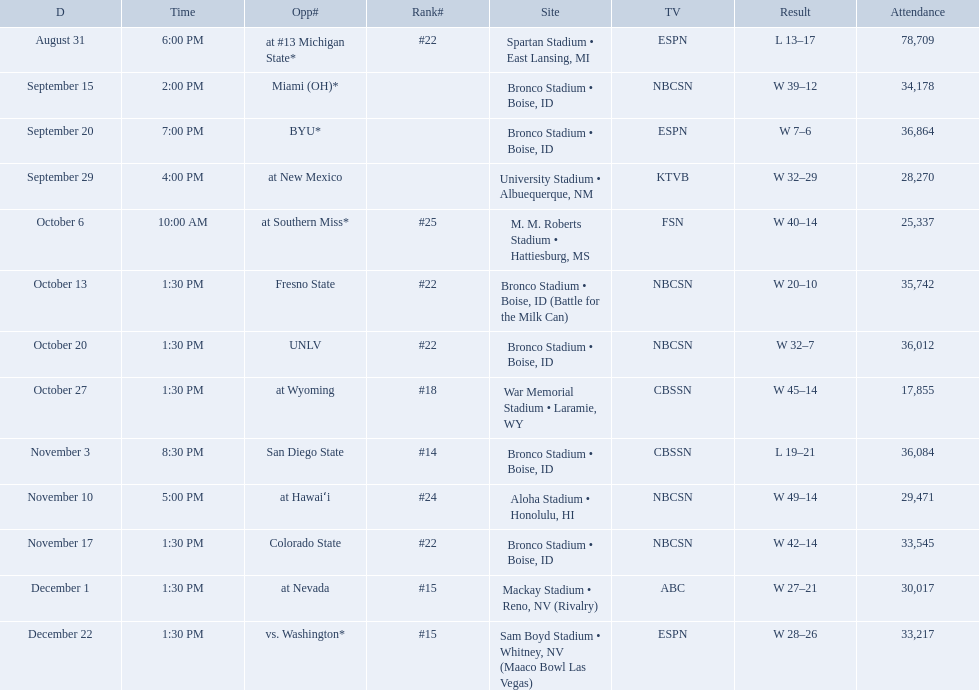What was the team's listed rankings for the season? #22, , , , #25, #22, #22, #18, #14, #24, #22, #15, #15. Which of these ranks is the best? #14. What are all of the rankings? #22, , , , #25, #22, #22, #18, #14, #24, #22, #15, #15. Which of them was the best position? #14. I'm looking to parse the entire table for insights. Could you assist me with that? {'header': ['D', 'Time', 'Opp#', 'Rank#', 'Site', 'TV', 'Result', 'Attendance'], 'rows': [['August 31', '6:00 PM', 'at\xa0#13\xa0Michigan State*', '#22', 'Spartan Stadium • East Lansing, MI', 'ESPN', 'L\xa013–17', '78,709'], ['September 15', '2:00 PM', 'Miami (OH)*', '', 'Bronco Stadium • Boise, ID', 'NBCSN', 'W\xa039–12', '34,178'], ['September 20', '7:00 PM', 'BYU*', '', 'Bronco Stadium • Boise, ID', 'ESPN', 'W\xa07–6', '36,864'], ['September 29', '4:00 PM', 'at\xa0New Mexico', '', 'University Stadium • Albuequerque, NM', 'KTVB', 'W\xa032–29', '28,270'], ['October 6', '10:00 AM', 'at\xa0Southern Miss*', '#25', 'M. M. Roberts Stadium • Hattiesburg, MS', 'FSN', 'W\xa040–14', '25,337'], ['October 13', '1:30 PM', 'Fresno State', '#22', 'Bronco Stadium • Boise, ID (Battle for the Milk Can)', 'NBCSN', 'W\xa020–10', '35,742'], ['October 20', '1:30 PM', 'UNLV', '#22', 'Bronco Stadium • Boise, ID', 'NBCSN', 'W\xa032–7', '36,012'], ['October 27', '1:30 PM', 'at\xa0Wyoming', '#18', 'War Memorial Stadium • Laramie, WY', 'CBSSN', 'W\xa045–14', '17,855'], ['November 3', '8:30 PM', 'San Diego State', '#14', 'Bronco Stadium • Boise, ID', 'CBSSN', 'L\xa019–21', '36,084'], ['November 10', '5:00 PM', 'at\xa0Hawaiʻi', '#24', 'Aloha Stadium • Honolulu, HI', 'NBCSN', 'W\xa049–14', '29,471'], ['November 17', '1:30 PM', 'Colorado State', '#22', 'Bronco Stadium • Boise, ID', 'NBCSN', 'W\xa042–14', '33,545'], ['December 1', '1:30 PM', 'at\xa0Nevada', '#15', 'Mackay Stadium • Reno, NV (Rivalry)', 'ABC', 'W\xa027–21', '30,017'], ['December 22', '1:30 PM', 'vs.\xa0Washington*', '#15', 'Sam Boyd Stadium • Whitney, NV (Maaco Bowl Las Vegas)', 'ESPN', 'W\xa028–26', '33,217']]} Who were all the opponents for boise state? At #13 michigan state*, miami (oh)*, byu*, at new mexico, at southern miss*, fresno state, unlv, at wyoming, san diego state, at hawaiʻi, colorado state, at nevada, vs. washington*. Which opponents were ranked? At #13 michigan state*, #22, at southern miss*, #25, fresno state, #22, unlv, #22, at wyoming, #18, san diego state, #14. Which opponent had the highest rank? San Diego State. 